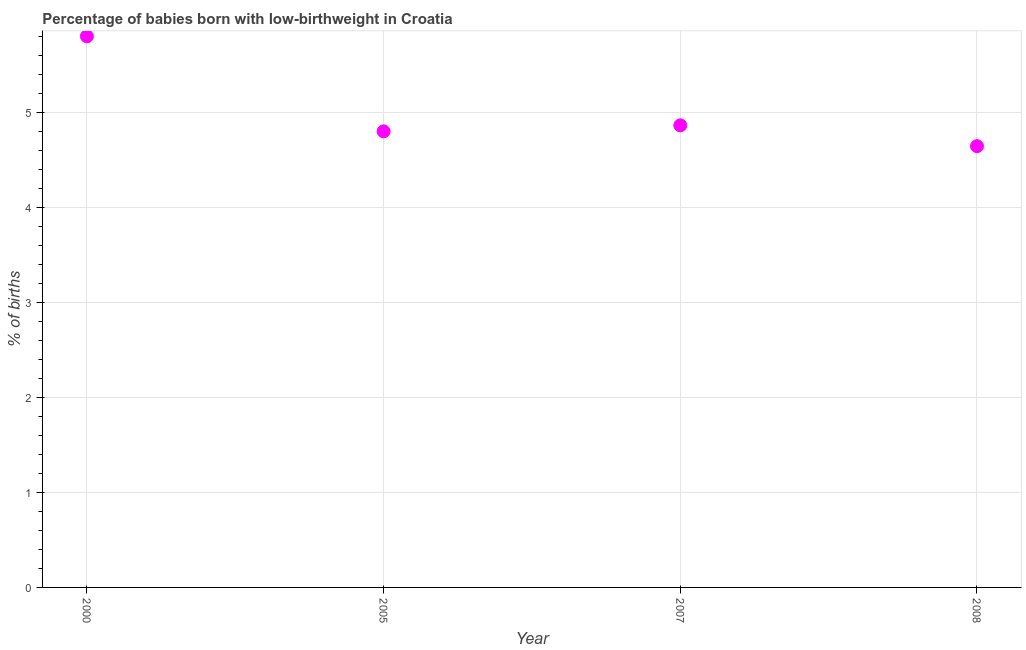What is the percentage of babies who were born with low-birthweight in 2007?
Make the answer very short. 4.86. Across all years, what is the maximum percentage of babies who were born with low-birthweight?
Your response must be concise. 5.8. Across all years, what is the minimum percentage of babies who were born with low-birthweight?
Your response must be concise. 4.64. What is the sum of the percentage of babies who were born with low-birthweight?
Your answer should be very brief. 20.11. What is the difference between the percentage of babies who were born with low-birthweight in 2005 and 2007?
Your answer should be very brief. -0.06. What is the average percentage of babies who were born with low-birthweight per year?
Your answer should be very brief. 5.03. What is the median percentage of babies who were born with low-birthweight?
Offer a very short reply. 4.83. What is the ratio of the percentage of babies who were born with low-birthweight in 2007 to that in 2008?
Keep it short and to the point. 1.05. What is the difference between the highest and the second highest percentage of babies who were born with low-birthweight?
Give a very brief answer. 0.94. What is the difference between the highest and the lowest percentage of babies who were born with low-birthweight?
Your answer should be compact. 1.16. In how many years, is the percentage of babies who were born with low-birthweight greater than the average percentage of babies who were born with low-birthweight taken over all years?
Offer a very short reply. 1. How many years are there in the graph?
Offer a terse response. 4. Does the graph contain any zero values?
Give a very brief answer. No. What is the title of the graph?
Your answer should be compact. Percentage of babies born with low-birthweight in Croatia. What is the label or title of the Y-axis?
Give a very brief answer. % of births. What is the % of births in 2005?
Keep it short and to the point. 4.8. What is the % of births in 2007?
Make the answer very short. 4.86. What is the % of births in 2008?
Offer a very short reply. 4.64. What is the difference between the % of births in 2000 and 2007?
Provide a succinct answer. 0.94. What is the difference between the % of births in 2000 and 2008?
Give a very brief answer. 1.16. What is the difference between the % of births in 2005 and 2007?
Ensure brevity in your answer.  -0.06. What is the difference between the % of births in 2005 and 2008?
Ensure brevity in your answer.  0.16. What is the difference between the % of births in 2007 and 2008?
Provide a short and direct response. 0.22. What is the ratio of the % of births in 2000 to that in 2005?
Offer a very short reply. 1.21. What is the ratio of the % of births in 2000 to that in 2007?
Give a very brief answer. 1.19. What is the ratio of the % of births in 2000 to that in 2008?
Your response must be concise. 1.25. What is the ratio of the % of births in 2005 to that in 2007?
Give a very brief answer. 0.99. What is the ratio of the % of births in 2005 to that in 2008?
Ensure brevity in your answer.  1.03. What is the ratio of the % of births in 2007 to that in 2008?
Your answer should be very brief. 1.05. 